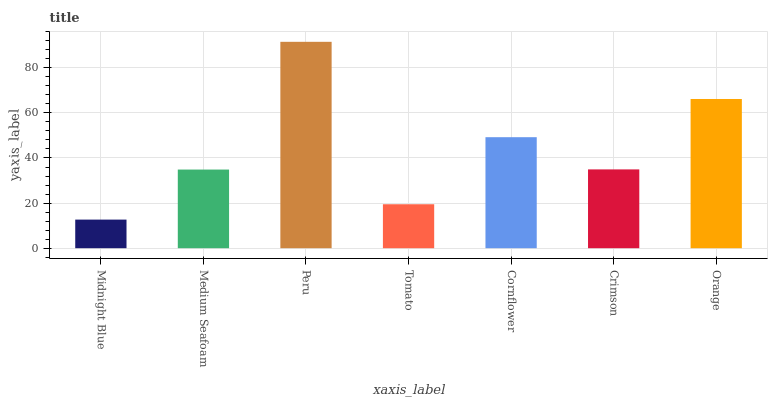Is Midnight Blue the minimum?
Answer yes or no. Yes. Is Peru the maximum?
Answer yes or no. Yes. Is Medium Seafoam the minimum?
Answer yes or no. No. Is Medium Seafoam the maximum?
Answer yes or no. No. Is Medium Seafoam greater than Midnight Blue?
Answer yes or no. Yes. Is Midnight Blue less than Medium Seafoam?
Answer yes or no. Yes. Is Midnight Blue greater than Medium Seafoam?
Answer yes or no. No. Is Medium Seafoam less than Midnight Blue?
Answer yes or no. No. Is Crimson the high median?
Answer yes or no. Yes. Is Crimson the low median?
Answer yes or no. Yes. Is Tomato the high median?
Answer yes or no. No. Is Medium Seafoam the low median?
Answer yes or no. No. 